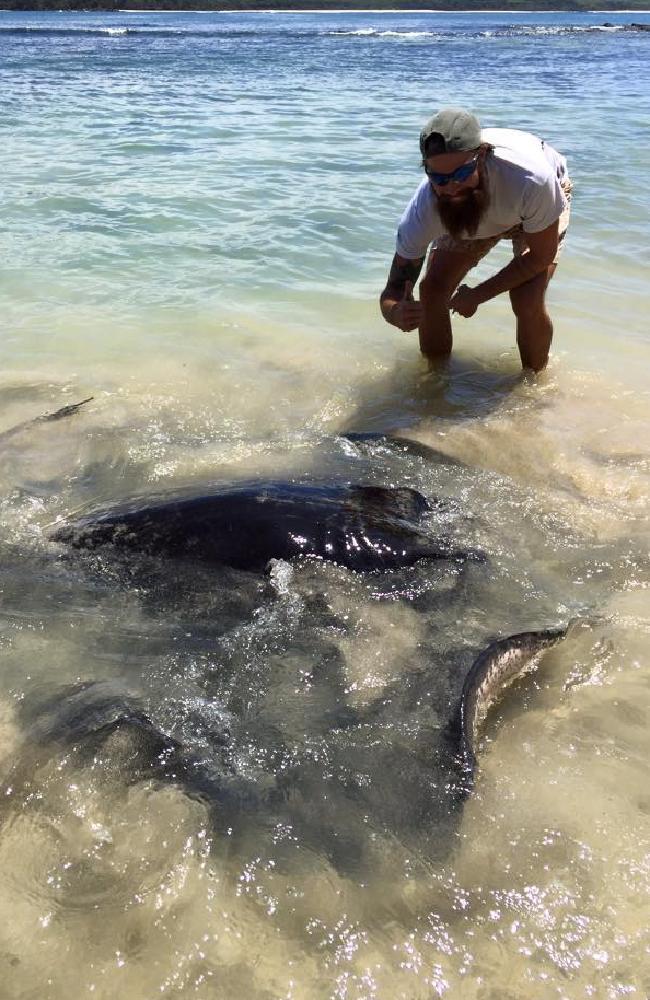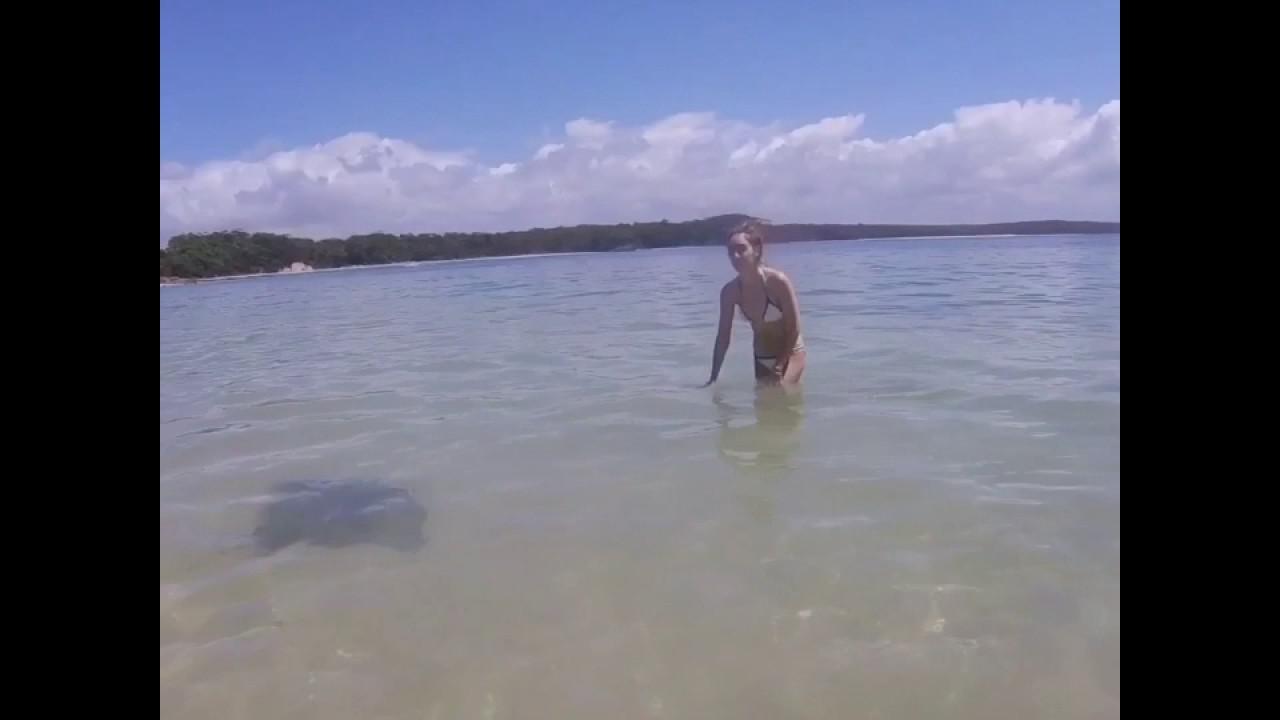The first image is the image on the left, the second image is the image on the right. For the images displayed, is the sentence "A man is interacting with a sea animal in the water." factually correct? Answer yes or no. Yes. The first image is the image on the left, the second image is the image on the right. For the images displayed, is the sentence "An image shows one man standing in water and bending toward a stingray." factually correct? Answer yes or no. Yes. 